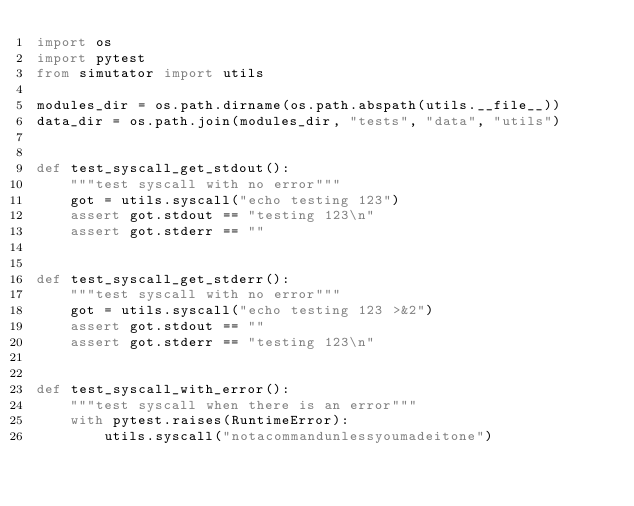Convert code to text. <code><loc_0><loc_0><loc_500><loc_500><_Python_>import os
import pytest
from simutator import utils

modules_dir = os.path.dirname(os.path.abspath(utils.__file__))
data_dir = os.path.join(modules_dir, "tests", "data", "utils")


def test_syscall_get_stdout():
    """test syscall with no error"""
    got = utils.syscall("echo testing 123")
    assert got.stdout == "testing 123\n"
    assert got.stderr == ""


def test_syscall_get_stderr():
    """test syscall with no error"""
    got = utils.syscall("echo testing 123 >&2")
    assert got.stdout == ""
    assert got.stderr == "testing 123\n"


def test_syscall_with_error():
    """test syscall when there is an error"""
    with pytest.raises(RuntimeError):
        utils.syscall("notacommandunlessyoumadeitone")
</code> 